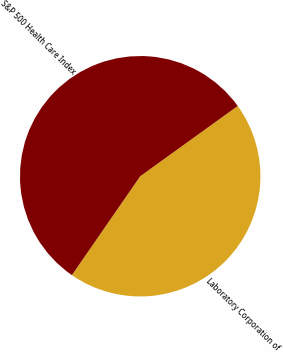Convert chart to OTSL. <chart><loc_0><loc_0><loc_500><loc_500><pie_chart><fcel>Laboratory Corporation of<fcel>S&P 500 Health Care Index<nl><fcel>44.56%<fcel>55.44%<nl></chart> 